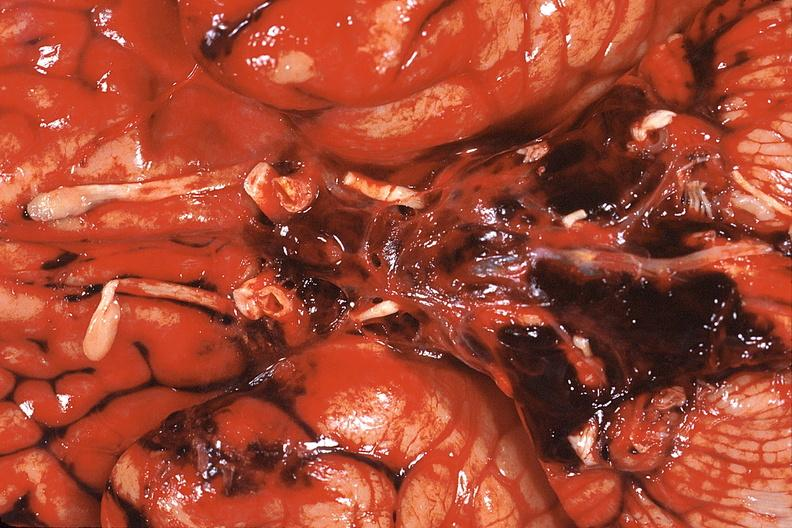what does this image show?
Answer the question using a single word or phrase. Brain 